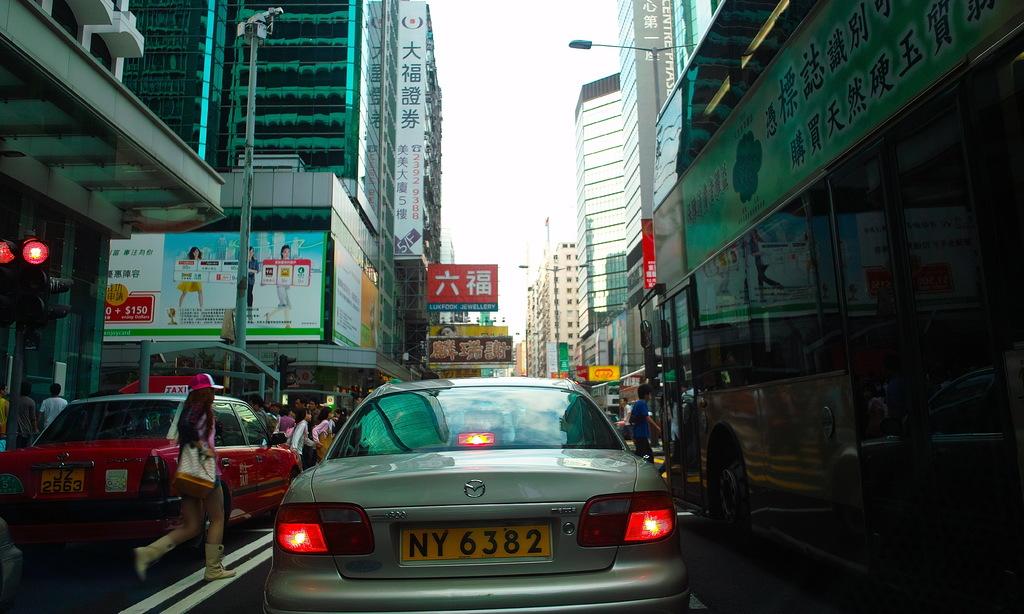What is the licence plate for the silver car?
Make the answer very short. Ny6382. Who made the silver car?
Give a very brief answer. Mazda. 